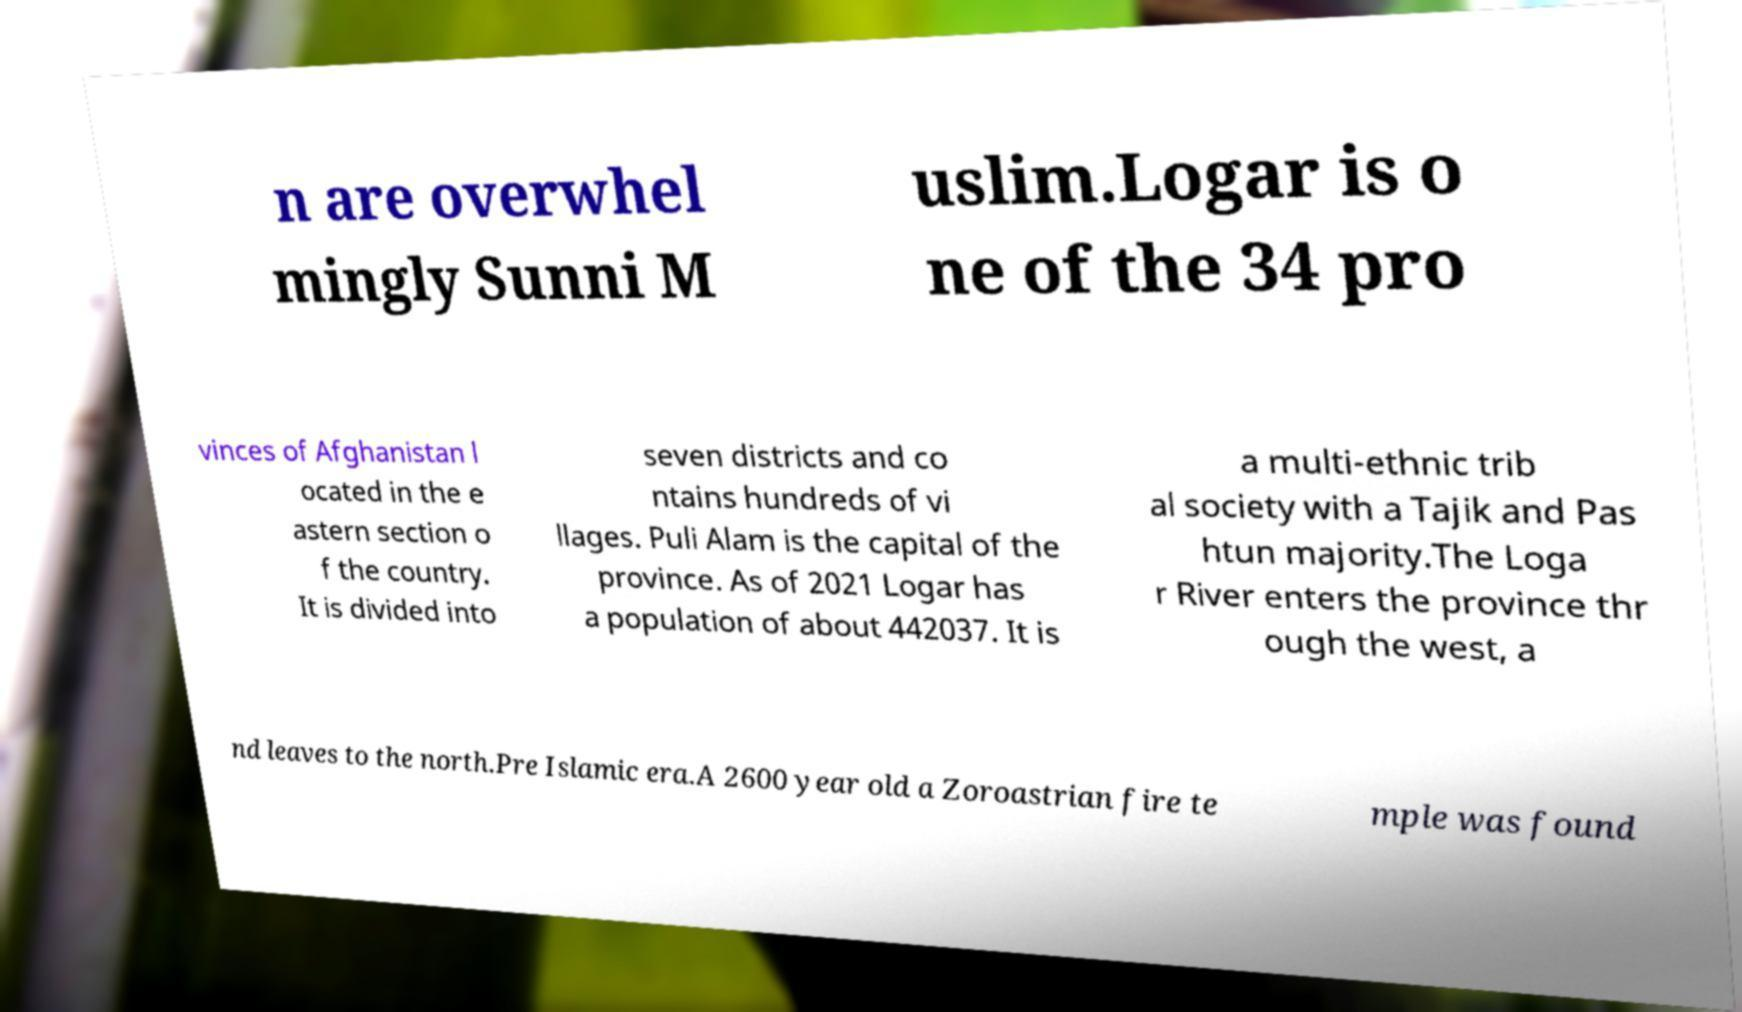Could you assist in decoding the text presented in this image and type it out clearly? n are overwhel mingly Sunni M uslim.Logar is o ne of the 34 pro vinces of Afghanistan l ocated in the e astern section o f the country. It is divided into seven districts and co ntains hundreds of vi llages. Puli Alam is the capital of the province. As of 2021 Logar has a population of about 442037. It is a multi-ethnic trib al society with a Tajik and Pas htun majority.The Loga r River enters the province thr ough the west, a nd leaves to the north.Pre Islamic era.A 2600 year old a Zoroastrian fire te mple was found 